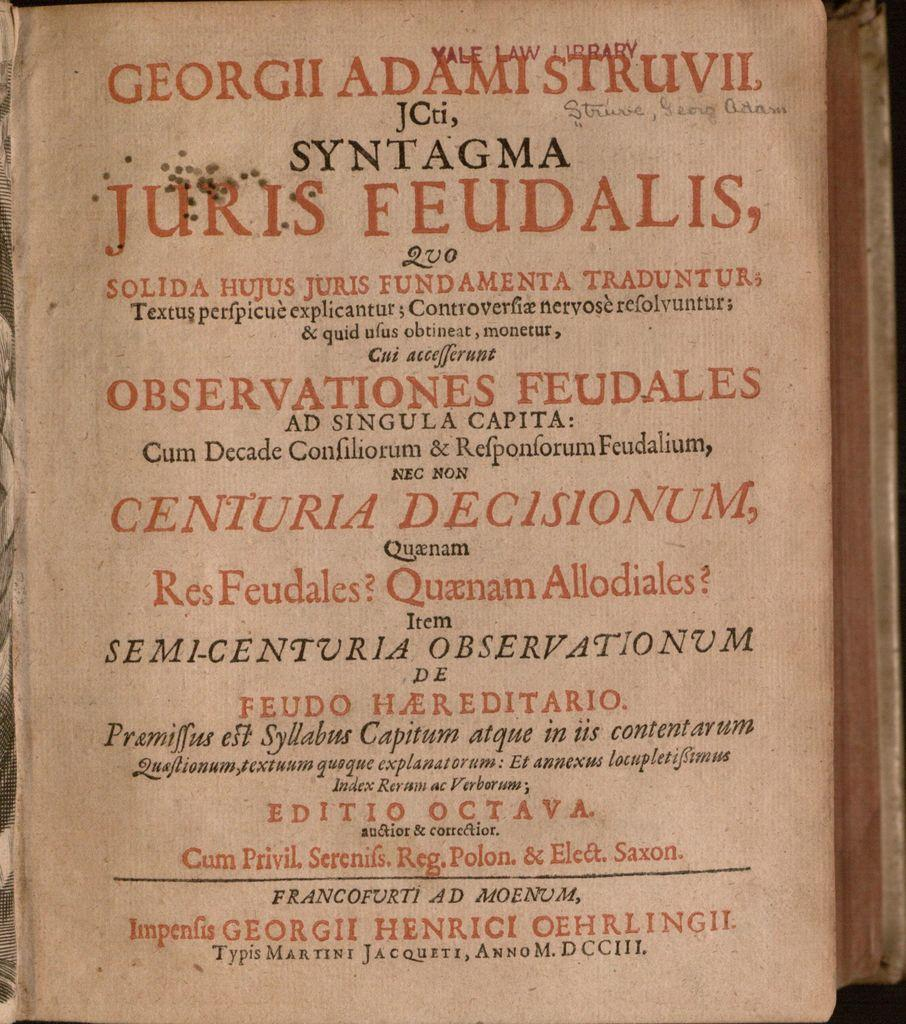<image>
Summarize the visual content of the image. old book with YALE LAW LIBRARY stamped in red at top 